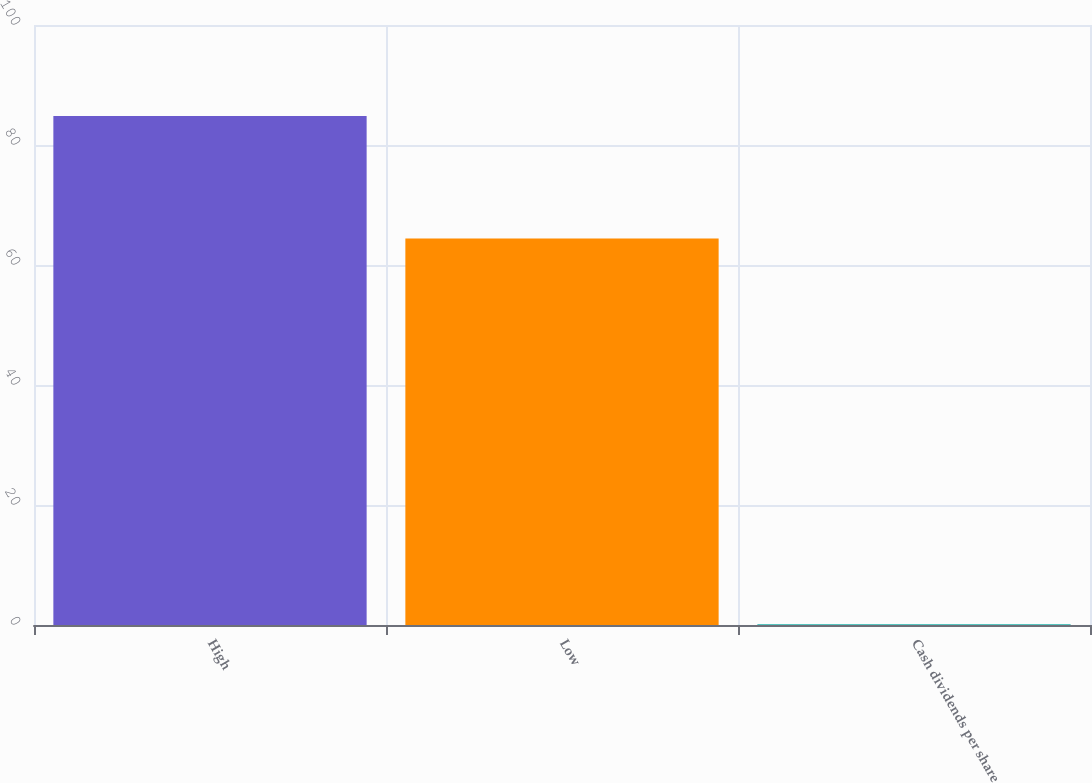Convert chart to OTSL. <chart><loc_0><loc_0><loc_500><loc_500><bar_chart><fcel>High<fcel>Low<fcel>Cash dividends per share<nl><fcel>84.83<fcel>64.4<fcel>0.12<nl></chart> 